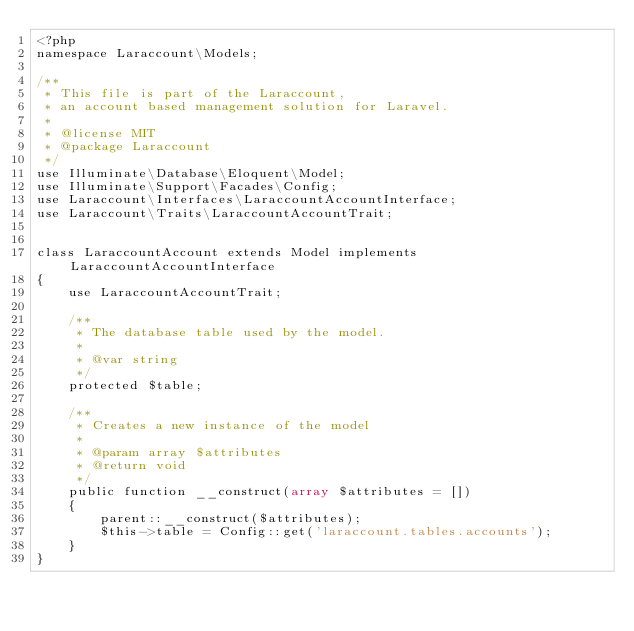<code> <loc_0><loc_0><loc_500><loc_500><_PHP_><?php
namespace Laraccount\Models;

/**
 * This file is part of the Laraccount,
 * an account based management solution for Laravel.
 *
 * @license MIT
 * @package Laraccount
 */
use Illuminate\Database\Eloquent\Model;
use Illuminate\Support\Facades\Config;
use Laraccount\Interfaces\LaraccountAccountInterface;
use Laraccount\Traits\LaraccountAccountTrait;


class LaraccountAccount extends Model implements LaraccountAccountInterface
{
    use LaraccountAccountTrait;

    /**
     * The database table used by the model.
     *
     * @var string
     */
    protected $table;

    /**
     * Creates a new instance of the model
     *
     * @param array $attributes
     * @return void
     */
    public function __construct(array $attributes = [])
    {
        parent::__construct($attributes);
        $this->table = Config::get('laraccount.tables.accounts');
    }
}
</code> 